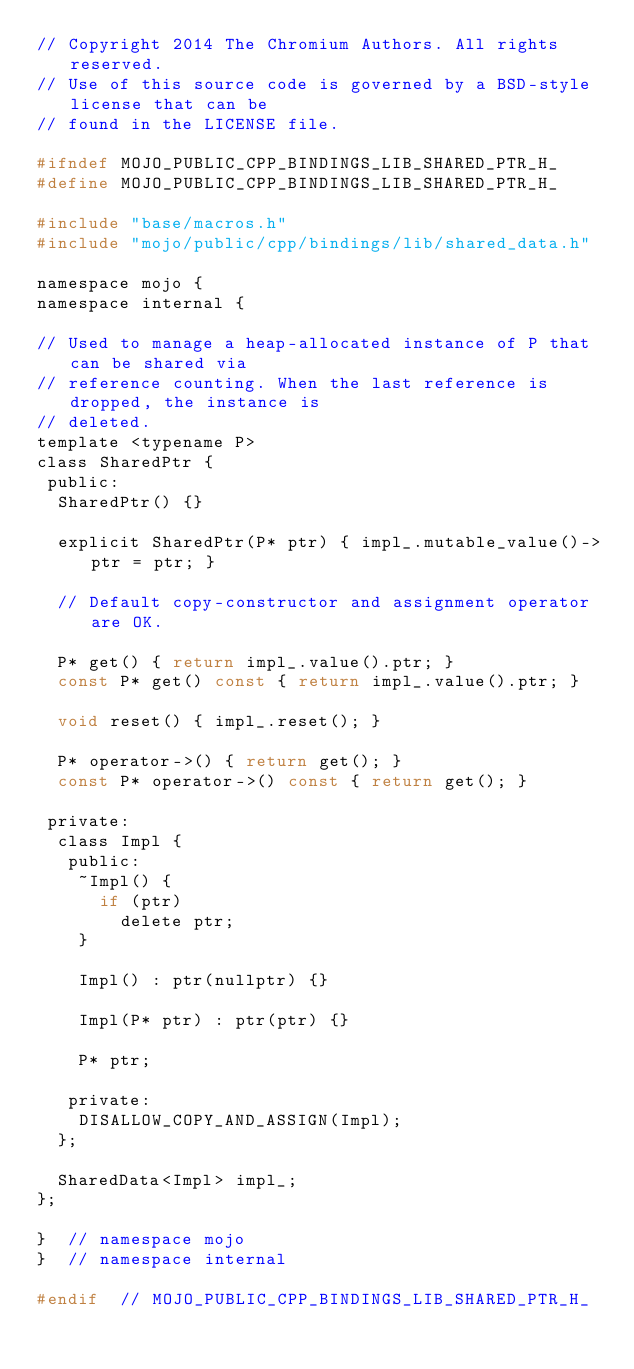<code> <loc_0><loc_0><loc_500><loc_500><_C_>// Copyright 2014 The Chromium Authors. All rights reserved.
// Use of this source code is governed by a BSD-style license that can be
// found in the LICENSE file.

#ifndef MOJO_PUBLIC_CPP_BINDINGS_LIB_SHARED_PTR_H_
#define MOJO_PUBLIC_CPP_BINDINGS_LIB_SHARED_PTR_H_

#include "base/macros.h"
#include "mojo/public/cpp/bindings/lib/shared_data.h"

namespace mojo {
namespace internal {

// Used to manage a heap-allocated instance of P that can be shared via
// reference counting. When the last reference is dropped, the instance is
// deleted.
template <typename P>
class SharedPtr {
 public:
  SharedPtr() {}

  explicit SharedPtr(P* ptr) { impl_.mutable_value()->ptr = ptr; }

  // Default copy-constructor and assignment operator are OK.

  P* get() { return impl_.value().ptr; }
  const P* get() const { return impl_.value().ptr; }

  void reset() { impl_.reset(); }

  P* operator->() { return get(); }
  const P* operator->() const { return get(); }

 private:
  class Impl {
   public:
    ~Impl() {
      if (ptr)
        delete ptr;
    }

    Impl() : ptr(nullptr) {}

    Impl(P* ptr) : ptr(ptr) {}

    P* ptr;

   private:
    DISALLOW_COPY_AND_ASSIGN(Impl);
  };

  SharedData<Impl> impl_;
};

}  // namespace mojo
}  // namespace internal

#endif  // MOJO_PUBLIC_CPP_BINDINGS_LIB_SHARED_PTR_H_
</code> 